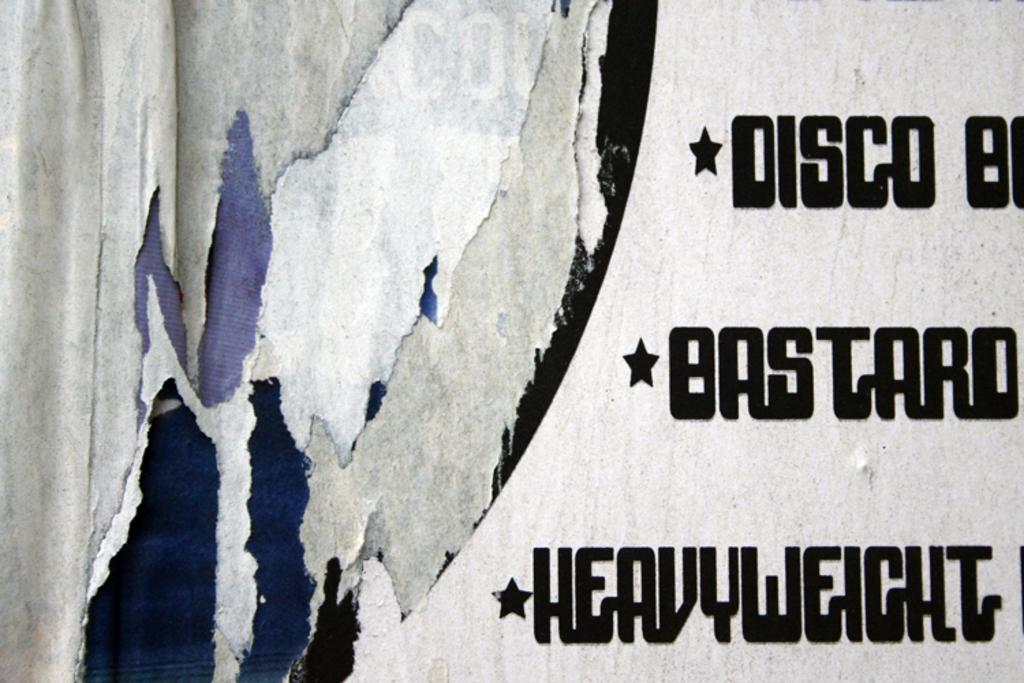<image>
Give a short and clear explanation of the subsequent image. a gray background with the word disco on the front 